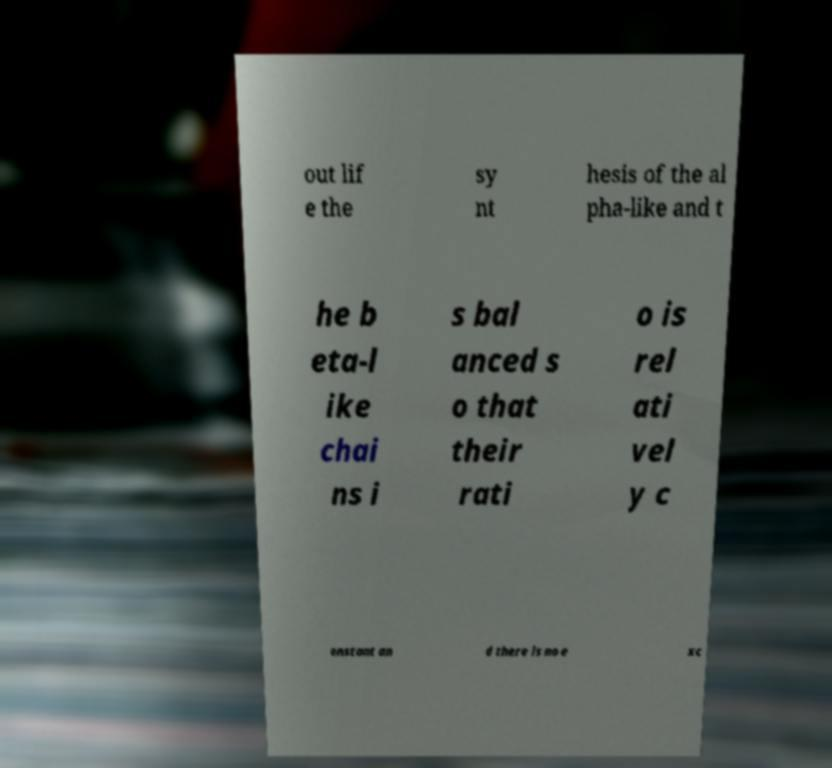I need the written content from this picture converted into text. Can you do that? out lif e the sy nt hesis of the al pha-like and t he b eta-l ike chai ns i s bal anced s o that their rati o is rel ati vel y c onstant an d there is no e xc 